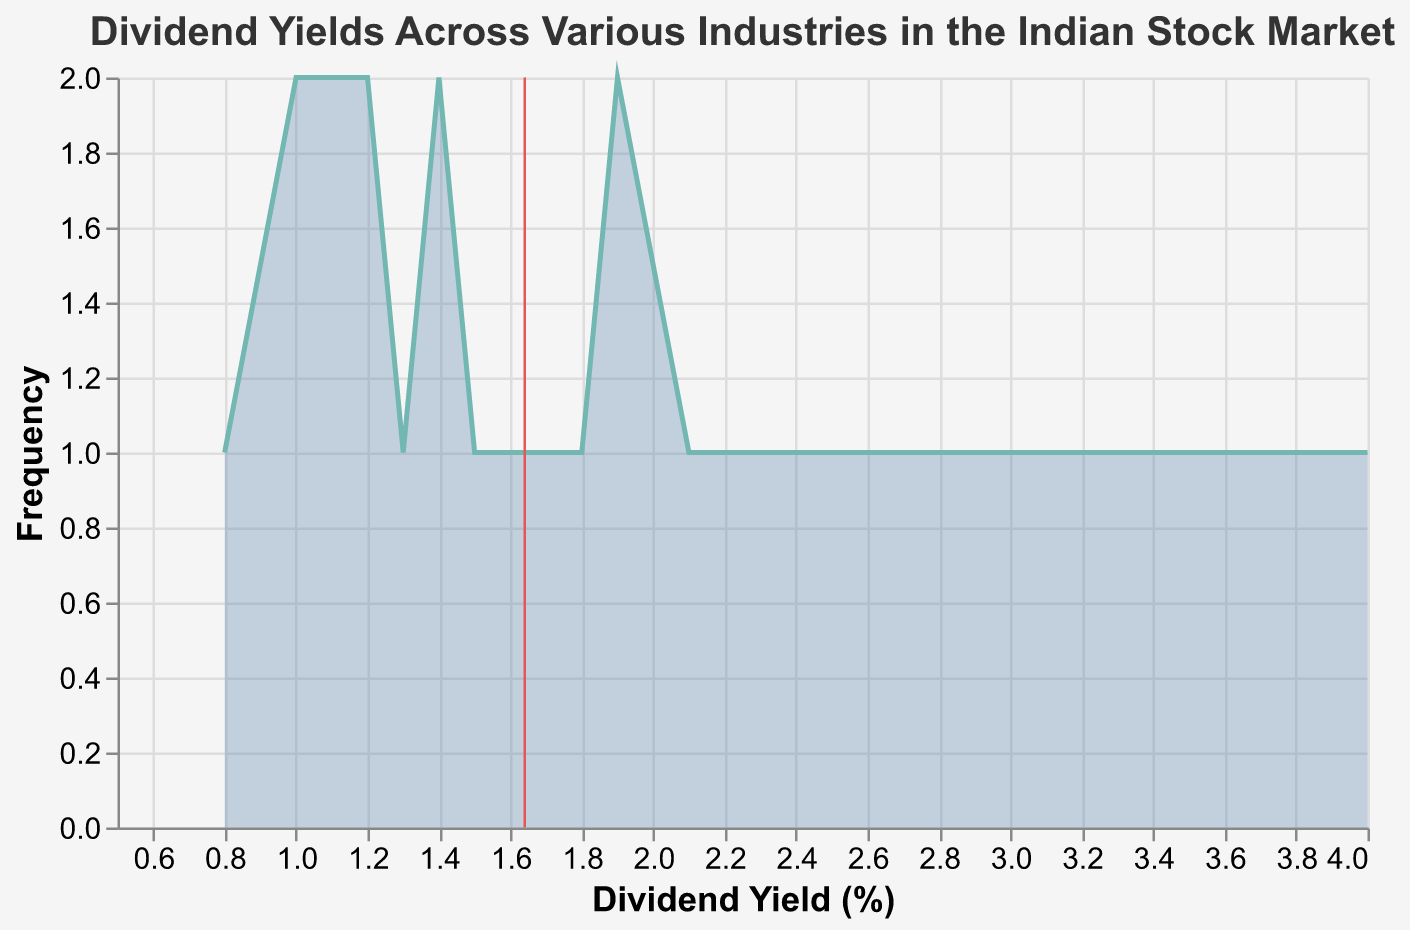What is the title of the plot? The title is typically displayed at the top of the plot. It provides the overall context of the data visualized in the plot.
Answer: Dividend Yields Across Various Industries in the Indian Stock Market How many different industries are represented in the plot? By examining the unique categories within the 'Industry' field on the x-axis, we can count the distinct industries displayed.
Answer: Five Which company has the highest dividend yield? By examining the data points in the plot, you can identify the company associated with the highest peak on the x-axis.
Answer: ITC What is the average dividend yield across all companies? The average is represented by the vertical line in the plot. It can be calculated by summing all dividend yields and dividing by the number of companies.
Answer: Approx. 1.7% How does the dividend yield of Consumer Goods companies compare to IT companies? By comparing the collective values of the dividend yields from Consumer Goods and IT companies, one can determine which industry typically has higher or lower yields.
Answer: Consumer Goods yield is generally higher Which industry has the lowest average dividend yield? To find which industry has the lowest average, you can calculate the mean dividend yield for each industry and compare.
Answer: Banking How many companies fall within the dividend yield range of 1.0% to 1.5%? Count the data points on the plot that fall within the specified range on the x-axis for Dividend Yield.
Answer: Eight What is the median dividend yield among all the companies? The median is the middle value of the ordered data set. To find it, rank the dividend yields and find the middle value.
Answer: Approx. 1.4% Is the mean dividend yield higher than the median dividend yield? Compare the mean (represented by the vertical line) with the median (the middle value of ordered data points).
Answer: Yes 